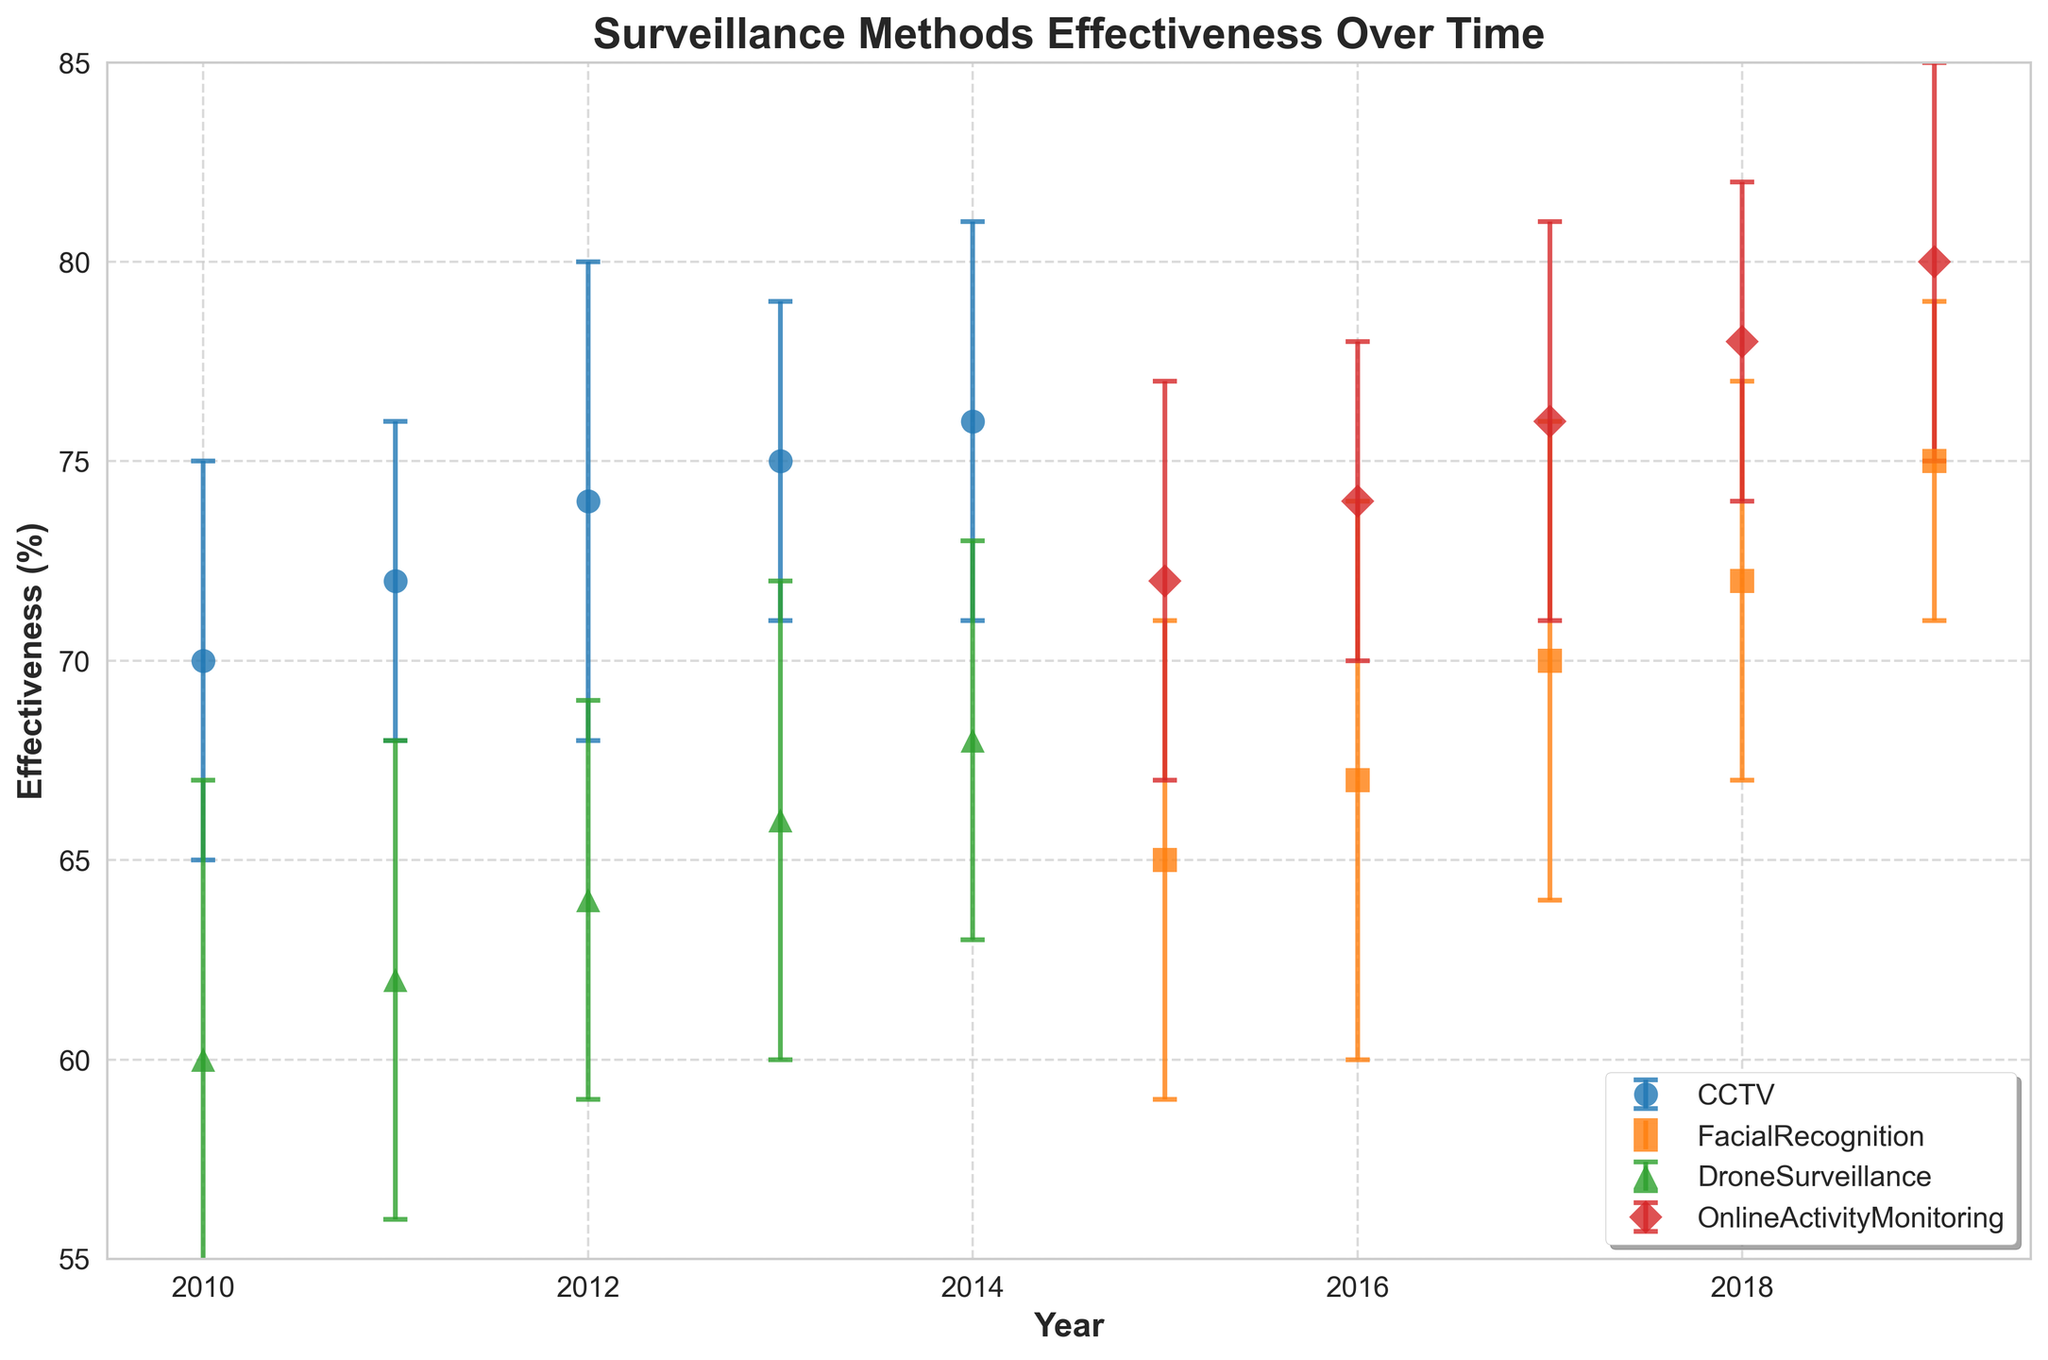what is the title of the plot? The title of the plot is found at the top and gives a summary of the visual data presented. In this case, the title is "Surveillance Methods Effectiveness Over Time".
Answer: Surveillance Methods Effectiveness Over Time How many surveillance methods are shown in the plot? To determine the number of surveillance methods, count the distinct legends or unique method labels in the plot. There are four different labels.
Answer: Four Which surveillance method has the highest effectiveness in 2019? Locate the data points for the year 2019 and compare their effectiveness values. The highest value belongs to OnlineActivityMonitoring with 80%.
Answer: OnlineActivityMonitoring What is the effectiveness of CCTV in 2012? Identify the data point corresponding to CCTV in the year 2012. The y-axis value for this point indicates the effectiveness, which is 74%.
Answer: 74% Which surveillance method shows the greatest improvement in effectiveness from the first year to the last year? Calculate the difference in effectiveness between the first and last year for each method and compare. OnlineActivityMonitoring starts at 72% in 2015 and ends at 80% in 2019, showing the greatest improvement of 8%.
Answer: OnlineActivityMonitoring What is the average effectiveness of FacialRecognition over the years shown? Sum the effectiveness of FacialRecognition for each year and divide by the number of years. (65 + 67 + 70 + 72 + 75) / 5 = 69.8%.
Answer: 69.8% Is there any year where all surveillance methods have overlapping error bars? Error bars overlap if the ranges intersect. Check for each year if the error bars' ranges for all methods intersect at any point. No single year shows all methods' error bars overlapping.
Answer: No Which surveillance method had the least increase in effectiveness over time? Calculate the change in effectiveness from the first to the last year for each method. CCTV changes from 70% in 2010 to 76% in 2014, an increase of 6%. DroneSurveillance goes from 60% in 2010 to 68% in 2014, the least increase of 8 over its timespan.
Answer: DroneSurveillance 